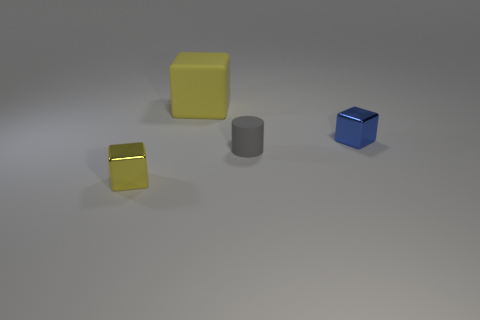Add 2 big red matte cubes. How many objects exist? 6 Subtract all cubes. How many objects are left? 1 Subtract all tiny purple metal cylinders. Subtract all large yellow rubber objects. How many objects are left? 3 Add 3 blue objects. How many blue objects are left? 4 Add 3 big yellow blocks. How many big yellow blocks exist? 4 Subtract 0 brown cubes. How many objects are left? 4 